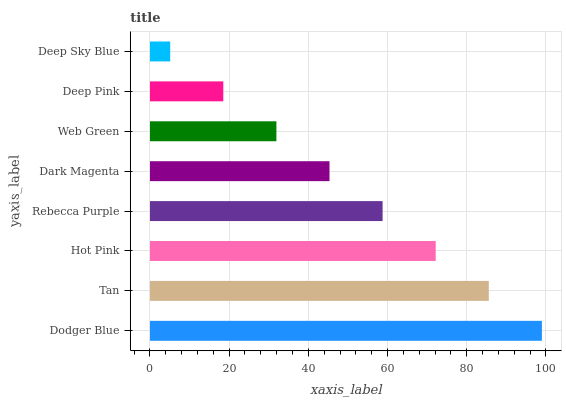Is Deep Sky Blue the minimum?
Answer yes or no. Yes. Is Dodger Blue the maximum?
Answer yes or no. Yes. Is Tan the minimum?
Answer yes or no. No. Is Tan the maximum?
Answer yes or no. No. Is Dodger Blue greater than Tan?
Answer yes or no. Yes. Is Tan less than Dodger Blue?
Answer yes or no. Yes. Is Tan greater than Dodger Blue?
Answer yes or no. No. Is Dodger Blue less than Tan?
Answer yes or no. No. Is Rebecca Purple the high median?
Answer yes or no. Yes. Is Dark Magenta the low median?
Answer yes or no. Yes. Is Dark Magenta the high median?
Answer yes or no. No. Is Hot Pink the low median?
Answer yes or no. No. 